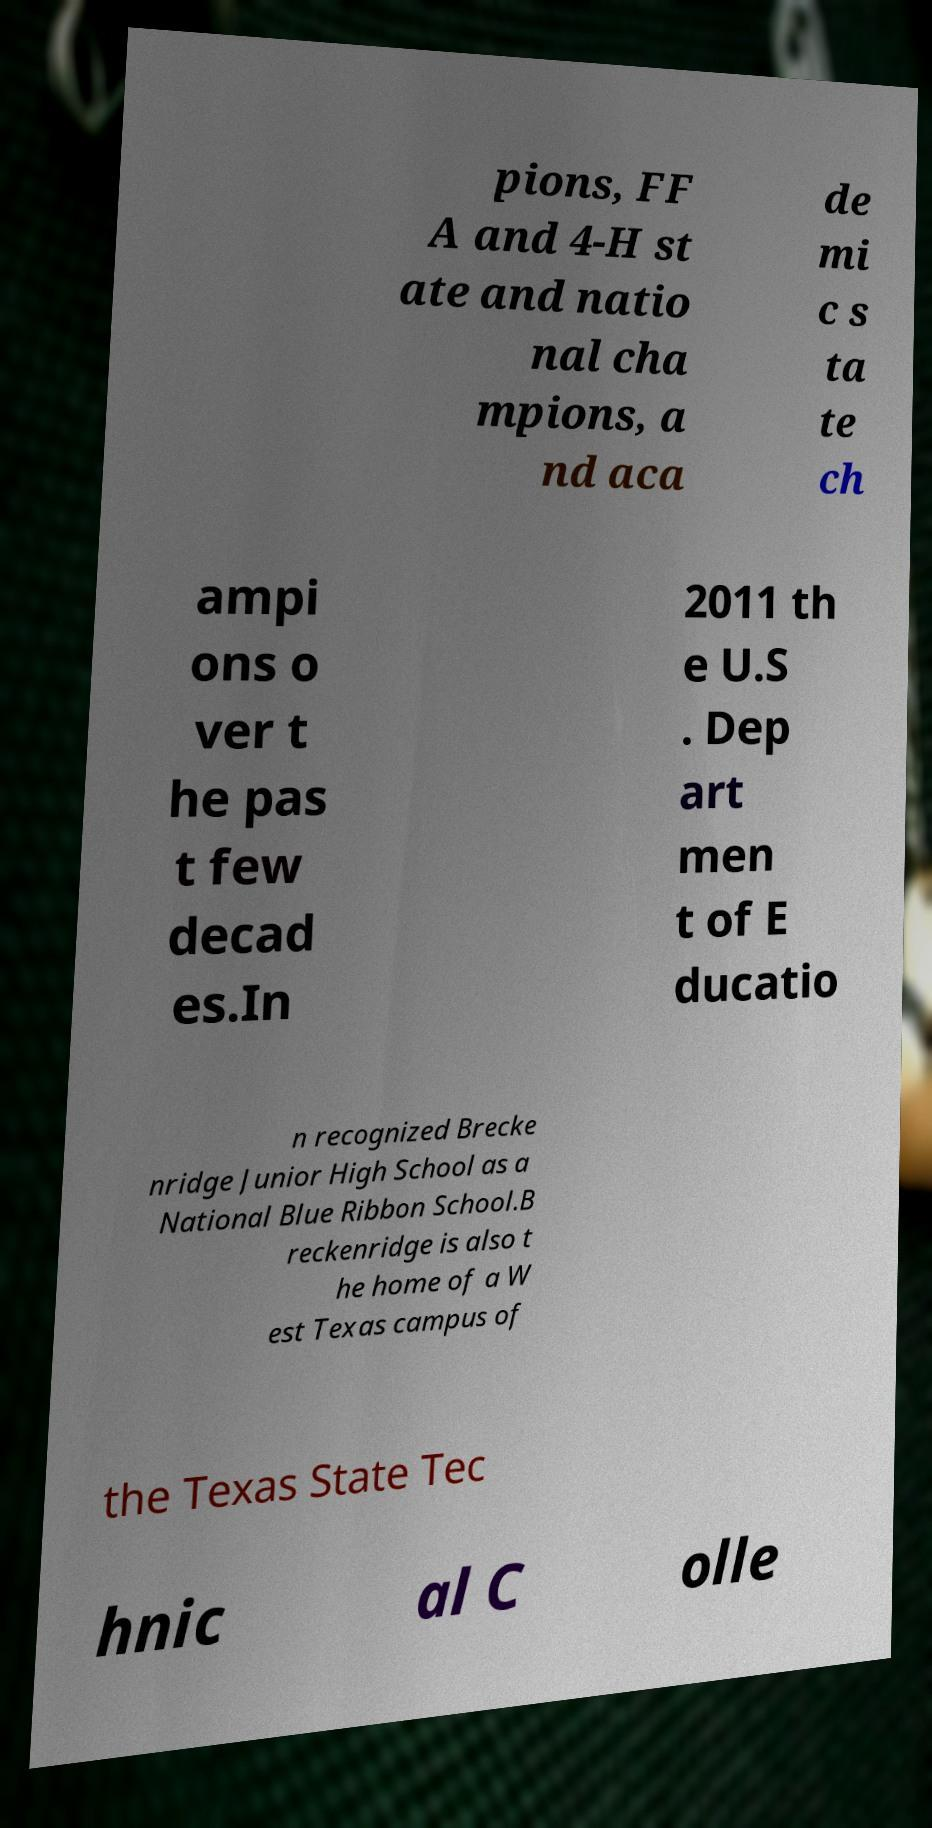I need the written content from this picture converted into text. Can you do that? pions, FF A and 4-H st ate and natio nal cha mpions, a nd aca de mi c s ta te ch ampi ons o ver t he pas t few decad es.In 2011 th e U.S . Dep art men t of E ducatio n recognized Brecke nridge Junior High School as a National Blue Ribbon School.B reckenridge is also t he home of a W est Texas campus of the Texas State Tec hnic al C olle 